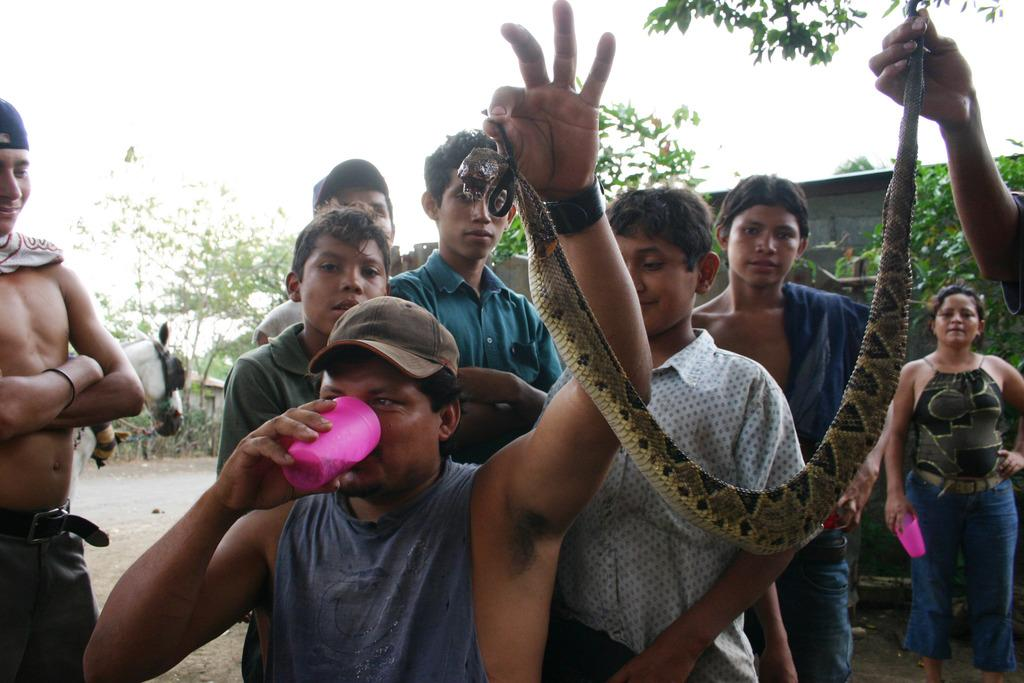What is happening in the image? There are people standing in the image, including a man holding a glass in one hand and a snake in the other hand. Can you describe the man's actions in the image? The man is holding a glass in one hand and a snake in the other hand. What might the man be doing with the glass? It is unclear what the man is doing with the glass, but he is holding it in his hand. What type of waste is visible in the image? There is no waste visible in the image. What color is the man's underwear in the image? The man's underwear is not visible in the image. 